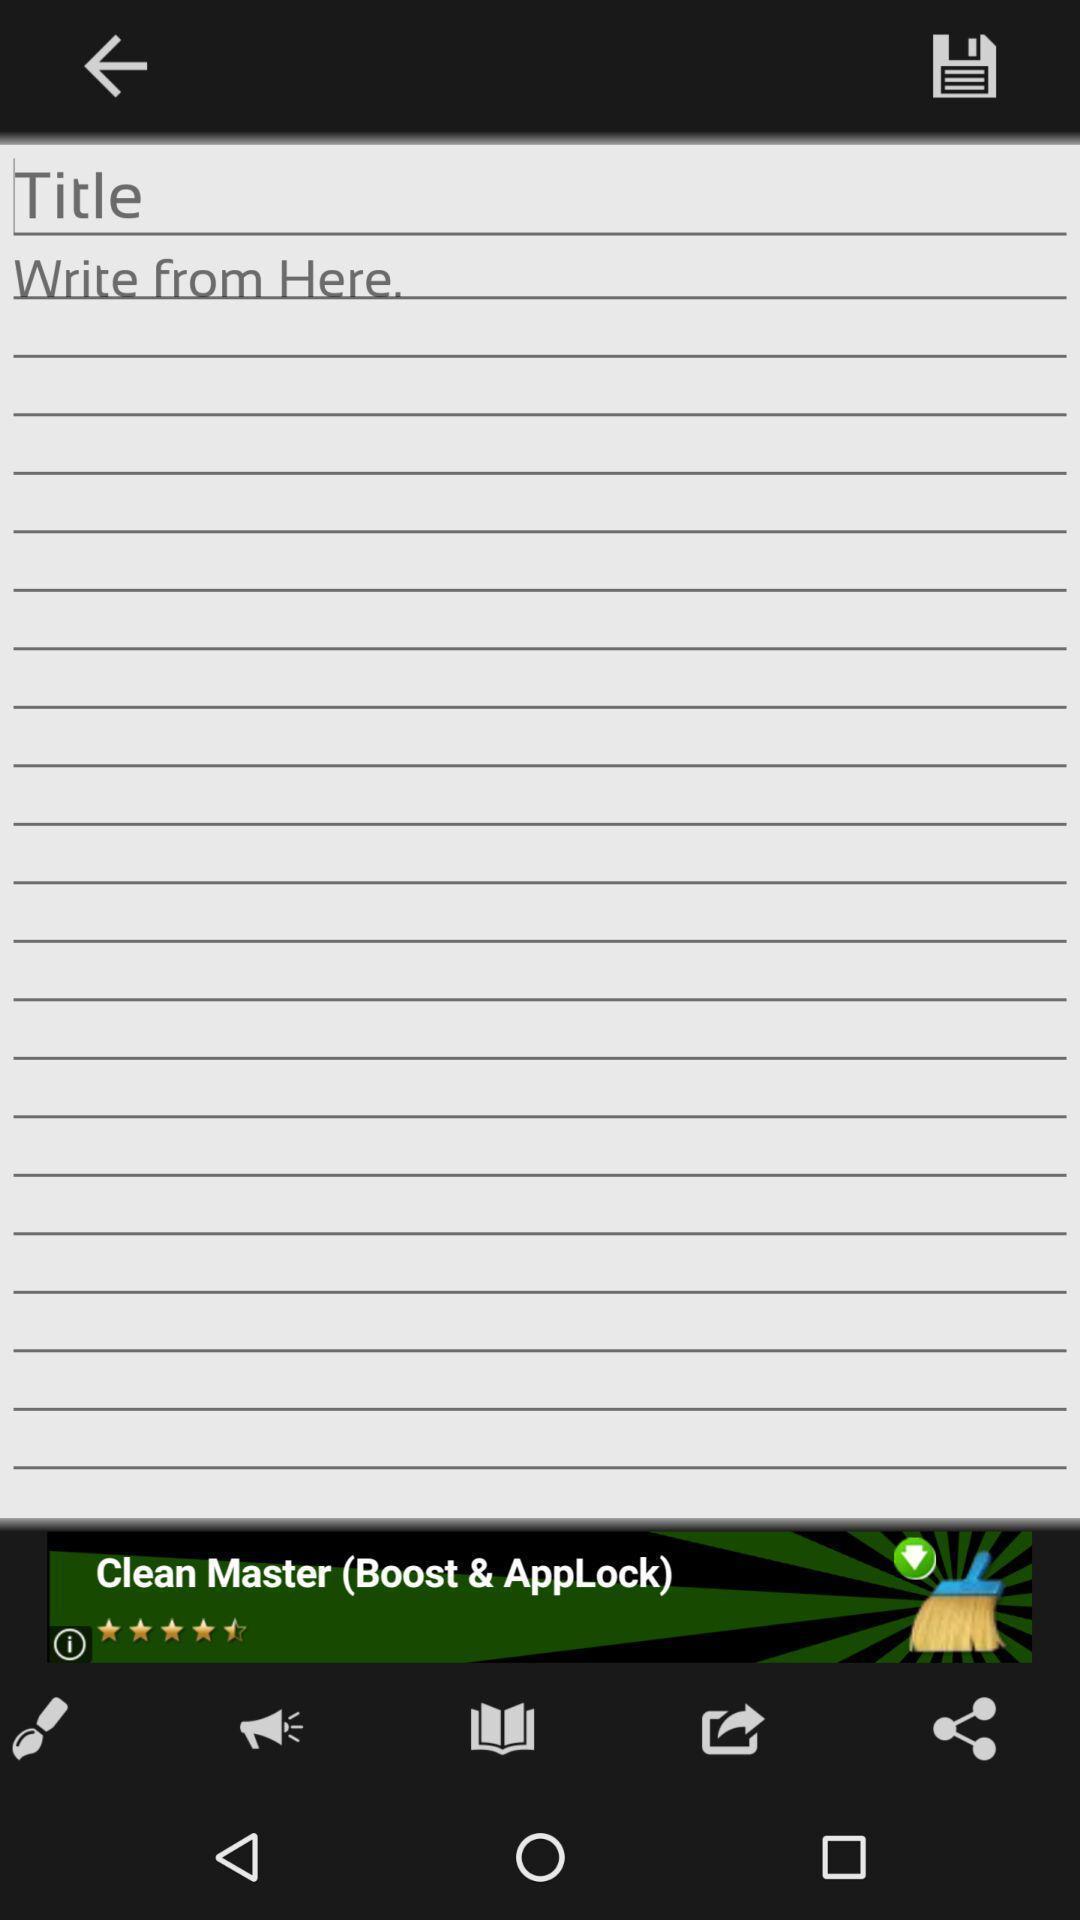Explain what's happening in this screen capture. Window displaying an app to write. 